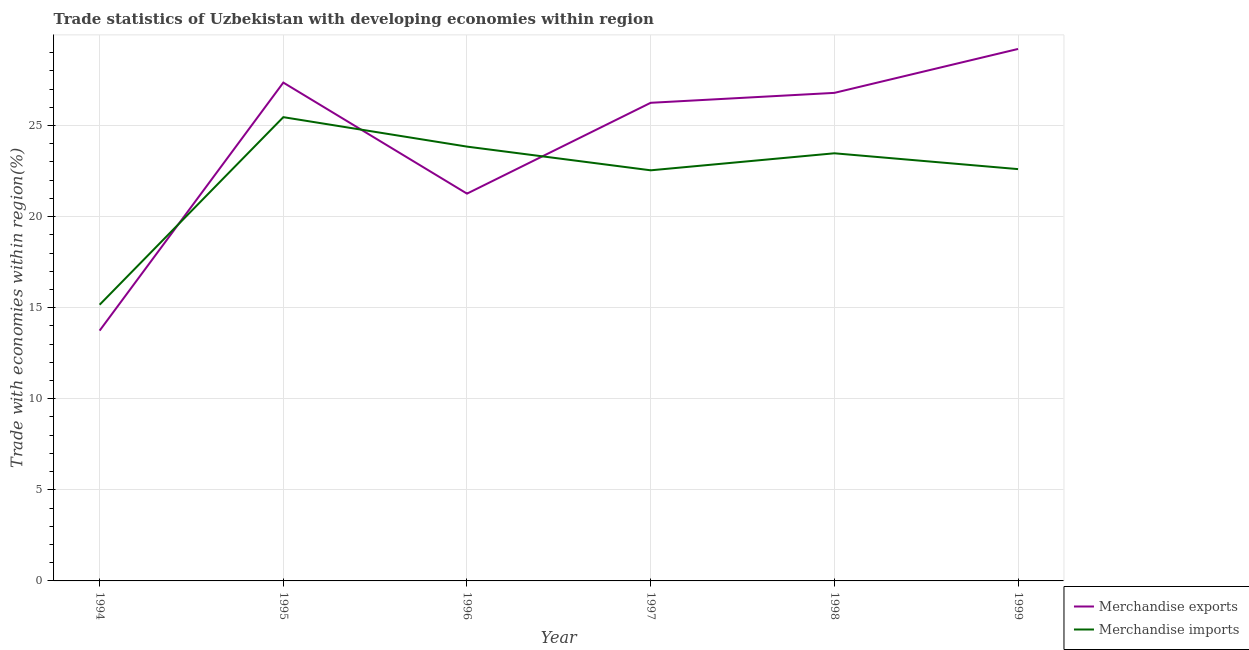Does the line corresponding to merchandise exports intersect with the line corresponding to merchandise imports?
Provide a short and direct response. Yes. What is the merchandise exports in 1994?
Offer a very short reply. 13.74. Across all years, what is the maximum merchandise exports?
Your response must be concise. 29.21. Across all years, what is the minimum merchandise imports?
Make the answer very short. 15.16. What is the total merchandise exports in the graph?
Give a very brief answer. 144.62. What is the difference between the merchandise exports in 1995 and that in 1997?
Your answer should be very brief. 1.11. What is the difference between the merchandise exports in 1999 and the merchandise imports in 1994?
Make the answer very short. 14.04. What is the average merchandise exports per year?
Make the answer very short. 24.1. In the year 1999, what is the difference between the merchandise exports and merchandise imports?
Provide a succinct answer. 6.6. What is the ratio of the merchandise exports in 1996 to that in 1998?
Your answer should be very brief. 0.79. Is the difference between the merchandise exports in 1996 and 1998 greater than the difference between the merchandise imports in 1996 and 1998?
Your answer should be very brief. No. What is the difference between the highest and the second highest merchandise exports?
Your answer should be compact. 1.85. What is the difference between the highest and the lowest merchandise imports?
Your answer should be very brief. 10.3. Is the sum of the merchandise exports in 1994 and 1995 greater than the maximum merchandise imports across all years?
Offer a very short reply. Yes. Does the merchandise exports monotonically increase over the years?
Your response must be concise. No. How many years are there in the graph?
Provide a short and direct response. 6. What is the difference between two consecutive major ticks on the Y-axis?
Make the answer very short. 5. Does the graph contain grids?
Your answer should be very brief. Yes. Where does the legend appear in the graph?
Offer a terse response. Bottom right. What is the title of the graph?
Provide a succinct answer. Trade statistics of Uzbekistan with developing economies within region. What is the label or title of the X-axis?
Provide a short and direct response. Year. What is the label or title of the Y-axis?
Your response must be concise. Trade with economies within region(%). What is the Trade with economies within region(%) of Merchandise exports in 1994?
Make the answer very short. 13.74. What is the Trade with economies within region(%) in Merchandise imports in 1994?
Offer a very short reply. 15.16. What is the Trade with economies within region(%) of Merchandise exports in 1995?
Your response must be concise. 27.36. What is the Trade with economies within region(%) in Merchandise imports in 1995?
Ensure brevity in your answer.  25.46. What is the Trade with economies within region(%) in Merchandise exports in 1996?
Keep it short and to the point. 21.26. What is the Trade with economies within region(%) of Merchandise imports in 1996?
Provide a short and direct response. 23.84. What is the Trade with economies within region(%) of Merchandise exports in 1997?
Your answer should be compact. 26.25. What is the Trade with economies within region(%) in Merchandise imports in 1997?
Make the answer very short. 22.54. What is the Trade with economies within region(%) of Merchandise exports in 1998?
Provide a short and direct response. 26.79. What is the Trade with economies within region(%) of Merchandise imports in 1998?
Offer a very short reply. 23.48. What is the Trade with economies within region(%) in Merchandise exports in 1999?
Offer a terse response. 29.21. What is the Trade with economies within region(%) of Merchandise imports in 1999?
Your answer should be compact. 22.61. Across all years, what is the maximum Trade with economies within region(%) of Merchandise exports?
Make the answer very short. 29.21. Across all years, what is the maximum Trade with economies within region(%) of Merchandise imports?
Your answer should be compact. 25.46. Across all years, what is the minimum Trade with economies within region(%) in Merchandise exports?
Offer a very short reply. 13.74. Across all years, what is the minimum Trade with economies within region(%) of Merchandise imports?
Provide a short and direct response. 15.16. What is the total Trade with economies within region(%) in Merchandise exports in the graph?
Your answer should be very brief. 144.62. What is the total Trade with economies within region(%) in Merchandise imports in the graph?
Your answer should be compact. 133.1. What is the difference between the Trade with economies within region(%) in Merchandise exports in 1994 and that in 1995?
Make the answer very short. -13.62. What is the difference between the Trade with economies within region(%) of Merchandise imports in 1994 and that in 1995?
Keep it short and to the point. -10.3. What is the difference between the Trade with economies within region(%) in Merchandise exports in 1994 and that in 1996?
Keep it short and to the point. -7.52. What is the difference between the Trade with economies within region(%) of Merchandise imports in 1994 and that in 1996?
Keep it short and to the point. -8.68. What is the difference between the Trade with economies within region(%) of Merchandise exports in 1994 and that in 1997?
Your answer should be very brief. -12.51. What is the difference between the Trade with economies within region(%) in Merchandise imports in 1994 and that in 1997?
Provide a succinct answer. -7.38. What is the difference between the Trade with economies within region(%) of Merchandise exports in 1994 and that in 1998?
Offer a very short reply. -13.05. What is the difference between the Trade with economies within region(%) of Merchandise imports in 1994 and that in 1998?
Keep it short and to the point. -8.31. What is the difference between the Trade with economies within region(%) of Merchandise exports in 1994 and that in 1999?
Offer a terse response. -15.46. What is the difference between the Trade with economies within region(%) in Merchandise imports in 1994 and that in 1999?
Provide a short and direct response. -7.44. What is the difference between the Trade with economies within region(%) in Merchandise exports in 1995 and that in 1996?
Make the answer very short. 6.1. What is the difference between the Trade with economies within region(%) in Merchandise imports in 1995 and that in 1996?
Give a very brief answer. 1.62. What is the difference between the Trade with economies within region(%) of Merchandise exports in 1995 and that in 1997?
Offer a very short reply. 1.11. What is the difference between the Trade with economies within region(%) of Merchandise imports in 1995 and that in 1997?
Keep it short and to the point. 2.92. What is the difference between the Trade with economies within region(%) in Merchandise exports in 1995 and that in 1998?
Provide a succinct answer. 0.57. What is the difference between the Trade with economies within region(%) of Merchandise imports in 1995 and that in 1998?
Give a very brief answer. 1.98. What is the difference between the Trade with economies within region(%) in Merchandise exports in 1995 and that in 1999?
Offer a terse response. -1.85. What is the difference between the Trade with economies within region(%) in Merchandise imports in 1995 and that in 1999?
Provide a succinct answer. 2.85. What is the difference between the Trade with economies within region(%) in Merchandise exports in 1996 and that in 1997?
Provide a succinct answer. -4.99. What is the difference between the Trade with economies within region(%) in Merchandise imports in 1996 and that in 1997?
Ensure brevity in your answer.  1.3. What is the difference between the Trade with economies within region(%) in Merchandise exports in 1996 and that in 1998?
Your answer should be compact. -5.53. What is the difference between the Trade with economies within region(%) of Merchandise imports in 1996 and that in 1998?
Offer a very short reply. 0.37. What is the difference between the Trade with economies within region(%) of Merchandise exports in 1996 and that in 1999?
Provide a short and direct response. -7.94. What is the difference between the Trade with economies within region(%) of Merchandise imports in 1996 and that in 1999?
Offer a very short reply. 1.24. What is the difference between the Trade with economies within region(%) in Merchandise exports in 1997 and that in 1998?
Your answer should be very brief. -0.54. What is the difference between the Trade with economies within region(%) of Merchandise imports in 1997 and that in 1998?
Ensure brevity in your answer.  -0.93. What is the difference between the Trade with economies within region(%) of Merchandise exports in 1997 and that in 1999?
Provide a succinct answer. -2.96. What is the difference between the Trade with economies within region(%) in Merchandise imports in 1997 and that in 1999?
Offer a very short reply. -0.07. What is the difference between the Trade with economies within region(%) in Merchandise exports in 1998 and that in 1999?
Make the answer very short. -2.41. What is the difference between the Trade with economies within region(%) of Merchandise imports in 1998 and that in 1999?
Make the answer very short. 0.87. What is the difference between the Trade with economies within region(%) in Merchandise exports in 1994 and the Trade with economies within region(%) in Merchandise imports in 1995?
Give a very brief answer. -11.72. What is the difference between the Trade with economies within region(%) of Merchandise exports in 1994 and the Trade with economies within region(%) of Merchandise imports in 1996?
Provide a short and direct response. -10.1. What is the difference between the Trade with economies within region(%) in Merchandise exports in 1994 and the Trade with economies within region(%) in Merchandise imports in 1997?
Give a very brief answer. -8.8. What is the difference between the Trade with economies within region(%) of Merchandise exports in 1994 and the Trade with economies within region(%) of Merchandise imports in 1998?
Make the answer very short. -9.74. What is the difference between the Trade with economies within region(%) of Merchandise exports in 1994 and the Trade with economies within region(%) of Merchandise imports in 1999?
Provide a succinct answer. -8.87. What is the difference between the Trade with economies within region(%) in Merchandise exports in 1995 and the Trade with economies within region(%) in Merchandise imports in 1996?
Offer a terse response. 3.52. What is the difference between the Trade with economies within region(%) in Merchandise exports in 1995 and the Trade with economies within region(%) in Merchandise imports in 1997?
Your response must be concise. 4.82. What is the difference between the Trade with economies within region(%) of Merchandise exports in 1995 and the Trade with economies within region(%) of Merchandise imports in 1998?
Offer a terse response. 3.88. What is the difference between the Trade with economies within region(%) of Merchandise exports in 1995 and the Trade with economies within region(%) of Merchandise imports in 1999?
Provide a succinct answer. 4.75. What is the difference between the Trade with economies within region(%) in Merchandise exports in 1996 and the Trade with economies within region(%) in Merchandise imports in 1997?
Keep it short and to the point. -1.28. What is the difference between the Trade with economies within region(%) of Merchandise exports in 1996 and the Trade with economies within region(%) of Merchandise imports in 1998?
Provide a succinct answer. -2.21. What is the difference between the Trade with economies within region(%) of Merchandise exports in 1996 and the Trade with economies within region(%) of Merchandise imports in 1999?
Provide a succinct answer. -1.35. What is the difference between the Trade with economies within region(%) of Merchandise exports in 1997 and the Trade with economies within region(%) of Merchandise imports in 1998?
Offer a very short reply. 2.77. What is the difference between the Trade with economies within region(%) in Merchandise exports in 1997 and the Trade with economies within region(%) in Merchandise imports in 1999?
Provide a short and direct response. 3.64. What is the difference between the Trade with economies within region(%) of Merchandise exports in 1998 and the Trade with economies within region(%) of Merchandise imports in 1999?
Offer a very short reply. 4.19. What is the average Trade with economies within region(%) of Merchandise exports per year?
Your response must be concise. 24.1. What is the average Trade with economies within region(%) of Merchandise imports per year?
Ensure brevity in your answer.  22.18. In the year 1994, what is the difference between the Trade with economies within region(%) of Merchandise exports and Trade with economies within region(%) of Merchandise imports?
Provide a succinct answer. -1.42. In the year 1995, what is the difference between the Trade with economies within region(%) of Merchandise exports and Trade with economies within region(%) of Merchandise imports?
Your answer should be very brief. 1.9. In the year 1996, what is the difference between the Trade with economies within region(%) in Merchandise exports and Trade with economies within region(%) in Merchandise imports?
Your response must be concise. -2.58. In the year 1997, what is the difference between the Trade with economies within region(%) in Merchandise exports and Trade with economies within region(%) in Merchandise imports?
Offer a very short reply. 3.71. In the year 1998, what is the difference between the Trade with economies within region(%) in Merchandise exports and Trade with economies within region(%) in Merchandise imports?
Offer a very short reply. 3.32. In the year 1999, what is the difference between the Trade with economies within region(%) of Merchandise exports and Trade with economies within region(%) of Merchandise imports?
Offer a terse response. 6.6. What is the ratio of the Trade with economies within region(%) in Merchandise exports in 1994 to that in 1995?
Keep it short and to the point. 0.5. What is the ratio of the Trade with economies within region(%) in Merchandise imports in 1994 to that in 1995?
Provide a succinct answer. 0.6. What is the ratio of the Trade with economies within region(%) of Merchandise exports in 1994 to that in 1996?
Your answer should be very brief. 0.65. What is the ratio of the Trade with economies within region(%) of Merchandise imports in 1994 to that in 1996?
Keep it short and to the point. 0.64. What is the ratio of the Trade with economies within region(%) in Merchandise exports in 1994 to that in 1997?
Your answer should be very brief. 0.52. What is the ratio of the Trade with economies within region(%) in Merchandise imports in 1994 to that in 1997?
Give a very brief answer. 0.67. What is the ratio of the Trade with economies within region(%) of Merchandise exports in 1994 to that in 1998?
Provide a short and direct response. 0.51. What is the ratio of the Trade with economies within region(%) in Merchandise imports in 1994 to that in 1998?
Provide a short and direct response. 0.65. What is the ratio of the Trade with economies within region(%) of Merchandise exports in 1994 to that in 1999?
Provide a succinct answer. 0.47. What is the ratio of the Trade with economies within region(%) of Merchandise imports in 1994 to that in 1999?
Your response must be concise. 0.67. What is the ratio of the Trade with economies within region(%) in Merchandise exports in 1995 to that in 1996?
Offer a very short reply. 1.29. What is the ratio of the Trade with economies within region(%) of Merchandise imports in 1995 to that in 1996?
Provide a short and direct response. 1.07. What is the ratio of the Trade with economies within region(%) in Merchandise exports in 1995 to that in 1997?
Provide a succinct answer. 1.04. What is the ratio of the Trade with economies within region(%) of Merchandise imports in 1995 to that in 1997?
Make the answer very short. 1.13. What is the ratio of the Trade with economies within region(%) of Merchandise exports in 1995 to that in 1998?
Provide a succinct answer. 1.02. What is the ratio of the Trade with economies within region(%) of Merchandise imports in 1995 to that in 1998?
Make the answer very short. 1.08. What is the ratio of the Trade with economies within region(%) of Merchandise exports in 1995 to that in 1999?
Offer a very short reply. 0.94. What is the ratio of the Trade with economies within region(%) in Merchandise imports in 1995 to that in 1999?
Give a very brief answer. 1.13. What is the ratio of the Trade with economies within region(%) in Merchandise exports in 1996 to that in 1997?
Offer a very short reply. 0.81. What is the ratio of the Trade with economies within region(%) in Merchandise imports in 1996 to that in 1997?
Make the answer very short. 1.06. What is the ratio of the Trade with economies within region(%) of Merchandise exports in 1996 to that in 1998?
Your response must be concise. 0.79. What is the ratio of the Trade with economies within region(%) of Merchandise imports in 1996 to that in 1998?
Offer a terse response. 1.02. What is the ratio of the Trade with economies within region(%) in Merchandise exports in 1996 to that in 1999?
Provide a succinct answer. 0.73. What is the ratio of the Trade with economies within region(%) of Merchandise imports in 1996 to that in 1999?
Provide a succinct answer. 1.05. What is the ratio of the Trade with economies within region(%) of Merchandise exports in 1997 to that in 1998?
Provide a succinct answer. 0.98. What is the ratio of the Trade with economies within region(%) of Merchandise imports in 1997 to that in 1998?
Offer a very short reply. 0.96. What is the ratio of the Trade with economies within region(%) of Merchandise exports in 1997 to that in 1999?
Offer a terse response. 0.9. What is the ratio of the Trade with economies within region(%) in Merchandise exports in 1998 to that in 1999?
Provide a short and direct response. 0.92. What is the ratio of the Trade with economies within region(%) in Merchandise imports in 1998 to that in 1999?
Your response must be concise. 1.04. What is the difference between the highest and the second highest Trade with economies within region(%) in Merchandise exports?
Provide a succinct answer. 1.85. What is the difference between the highest and the second highest Trade with economies within region(%) in Merchandise imports?
Your answer should be compact. 1.62. What is the difference between the highest and the lowest Trade with economies within region(%) of Merchandise exports?
Make the answer very short. 15.46. What is the difference between the highest and the lowest Trade with economies within region(%) of Merchandise imports?
Your answer should be very brief. 10.3. 